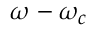Convert formula to latex. <formula><loc_0><loc_0><loc_500><loc_500>\omega - \omega _ { c }</formula> 